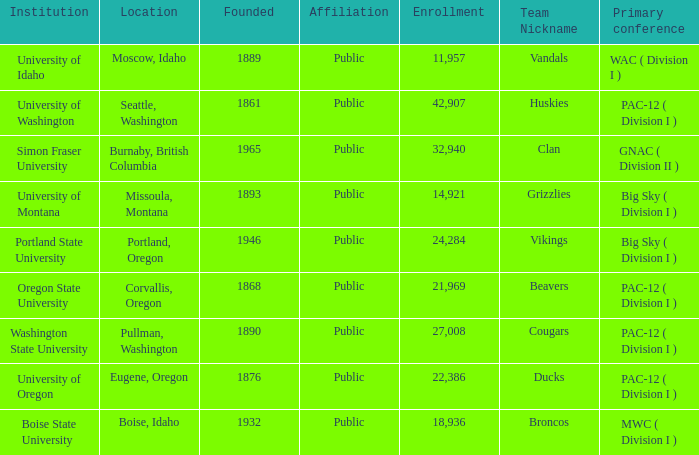What is the location of the team nicknamed Broncos, which was founded after 1889? Boise, Idaho. 